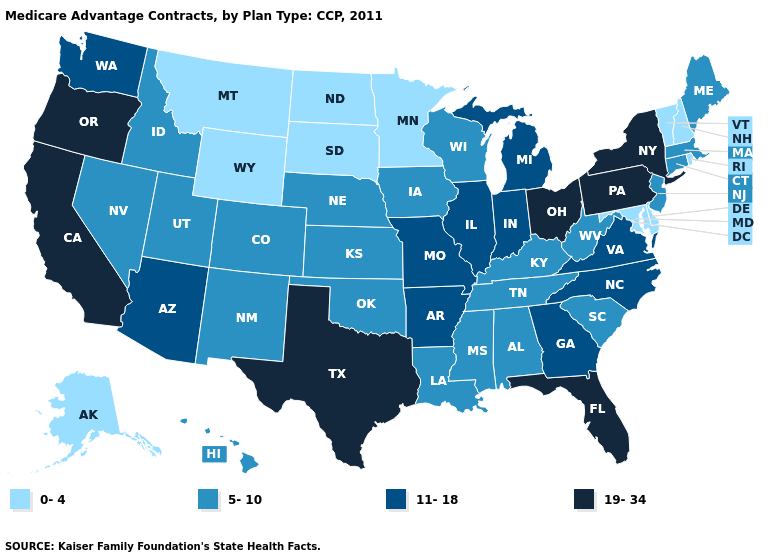Among the states that border Michigan , does Ohio have the lowest value?
Concise answer only. No. How many symbols are there in the legend?
Keep it brief. 4. Name the states that have a value in the range 5-10?
Be succinct. Alabama, Colorado, Connecticut, Hawaii, Iowa, Idaho, Kansas, Kentucky, Louisiana, Massachusetts, Maine, Mississippi, Nebraska, New Jersey, New Mexico, Nevada, Oklahoma, South Carolina, Tennessee, Utah, Wisconsin, West Virginia. What is the highest value in states that border New Jersey?
Quick response, please. 19-34. What is the highest value in states that border Kentucky?
Concise answer only. 19-34. Which states have the highest value in the USA?
Concise answer only. California, Florida, New York, Ohio, Oregon, Pennsylvania, Texas. Among the states that border Utah , does Arizona have the lowest value?
Be succinct. No. What is the value of Ohio?
Keep it brief. 19-34. Among the states that border Colorado , which have the highest value?
Quick response, please. Arizona. Does Minnesota have the highest value in the USA?
Short answer required. No. Name the states that have a value in the range 11-18?
Give a very brief answer. Arkansas, Arizona, Georgia, Illinois, Indiana, Michigan, Missouri, North Carolina, Virginia, Washington. What is the value of North Dakota?
Quick response, please. 0-4. What is the value of Pennsylvania?
Short answer required. 19-34. Name the states that have a value in the range 5-10?
Short answer required. Alabama, Colorado, Connecticut, Hawaii, Iowa, Idaho, Kansas, Kentucky, Louisiana, Massachusetts, Maine, Mississippi, Nebraska, New Jersey, New Mexico, Nevada, Oklahoma, South Carolina, Tennessee, Utah, Wisconsin, West Virginia. 